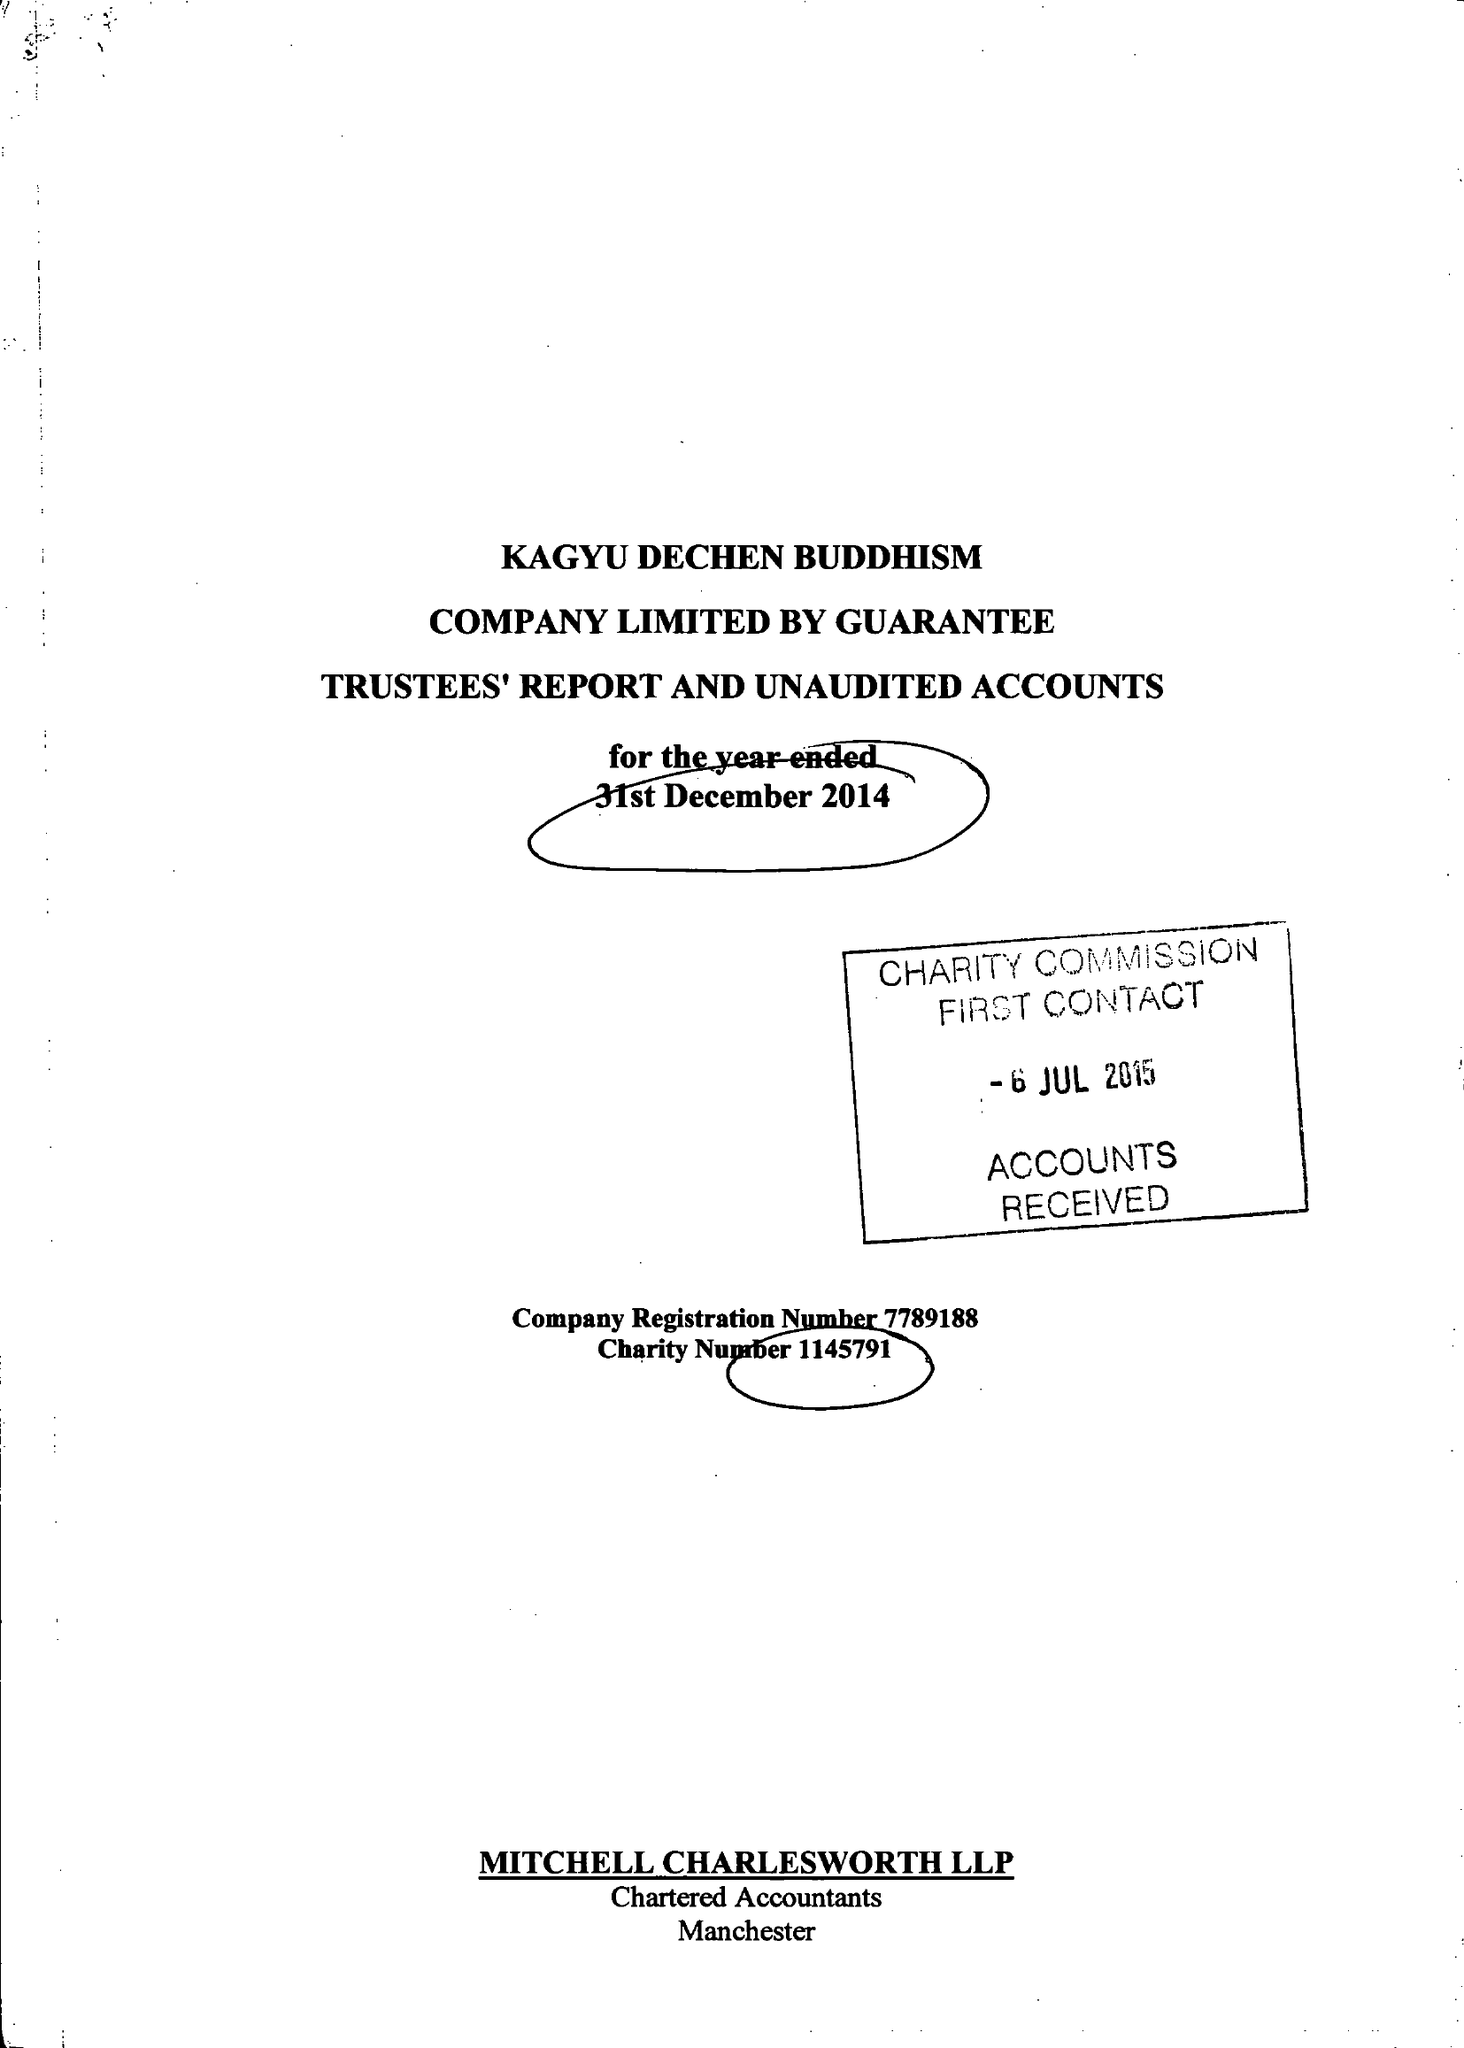What is the value for the charity_number?
Answer the question using a single word or phrase. 1145791 